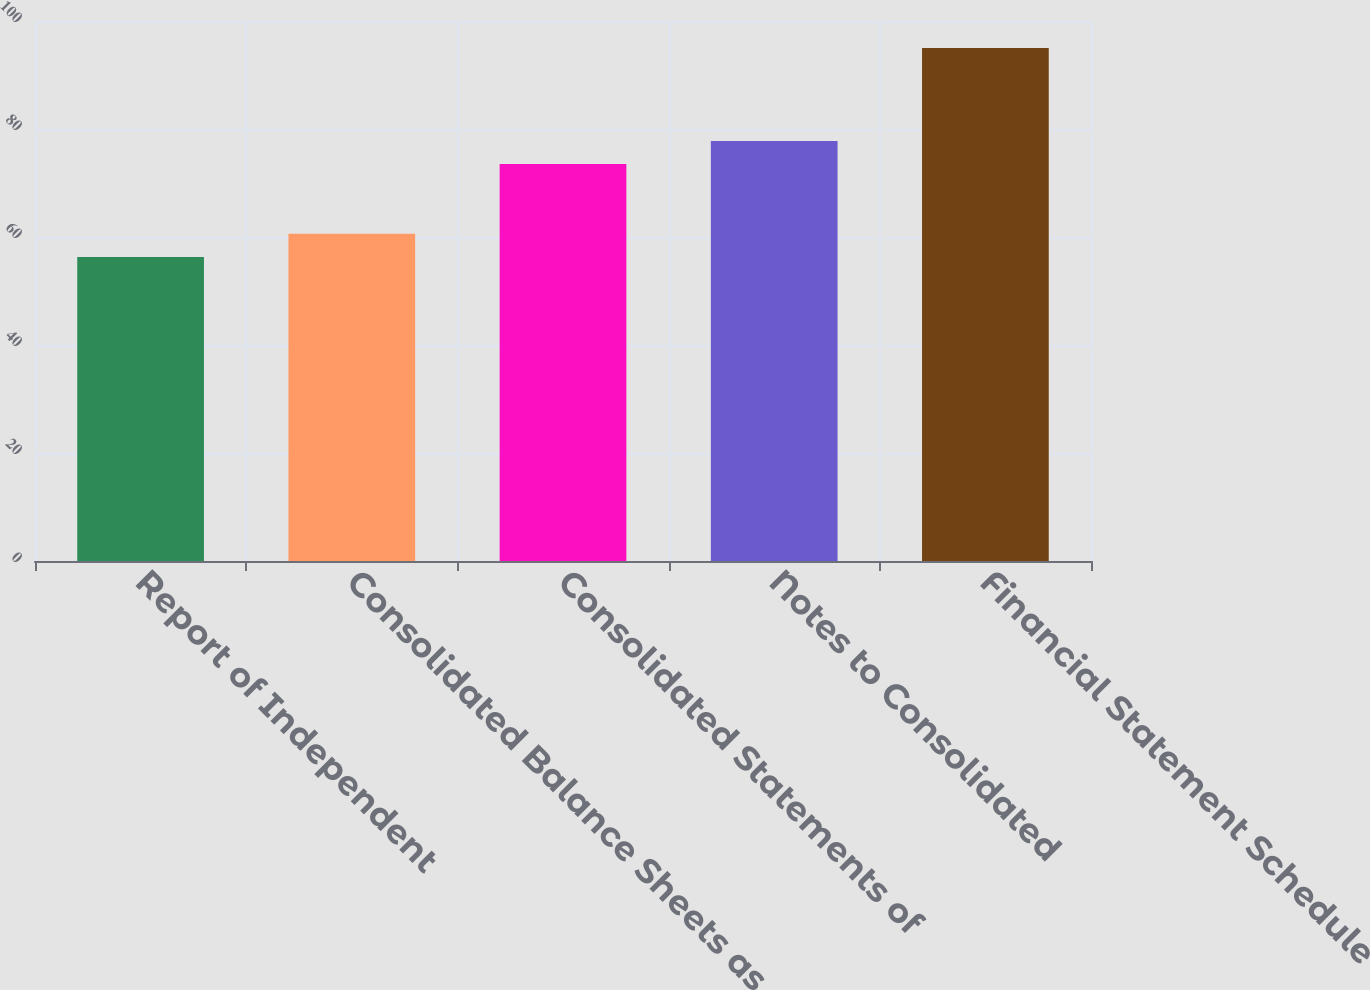Convert chart. <chart><loc_0><loc_0><loc_500><loc_500><bar_chart><fcel>Report of Independent<fcel>Consolidated Balance Sheets as<fcel>Consolidated Statements of<fcel>Notes to Consolidated<fcel>Financial Statement Schedule<nl><fcel>56.3<fcel>60.6<fcel>73.5<fcel>77.8<fcel>95<nl></chart> 